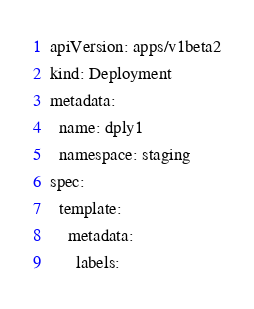Convert code to text. <code><loc_0><loc_0><loc_500><loc_500><_YAML_>apiVersion: apps/v1beta2
kind: Deployment
metadata:
  name: dply1
  namespace: staging
spec:
  template:
    metadata:
      labels:</code> 